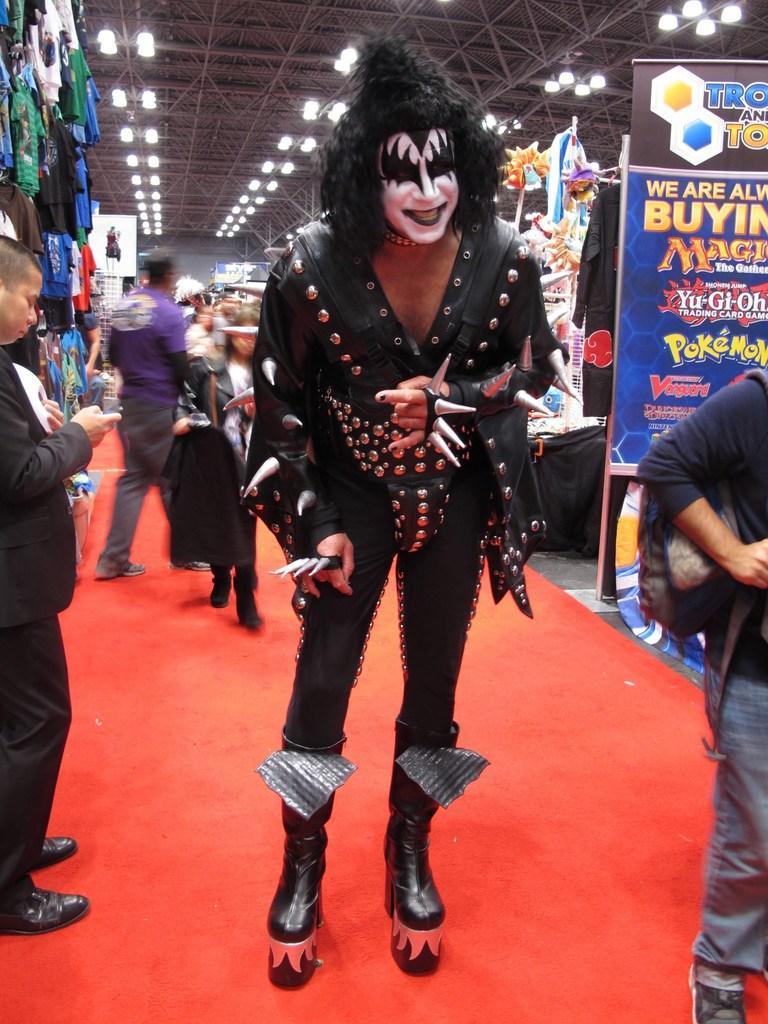In one or two sentences, can you explain what this image depicts? In this image, we can see a person wearing a costume and standing on the red carpet. Here we can see people. In the background, we can see clothes, banners, wall and few objects. At the top of the image, we can see rods and lights. 